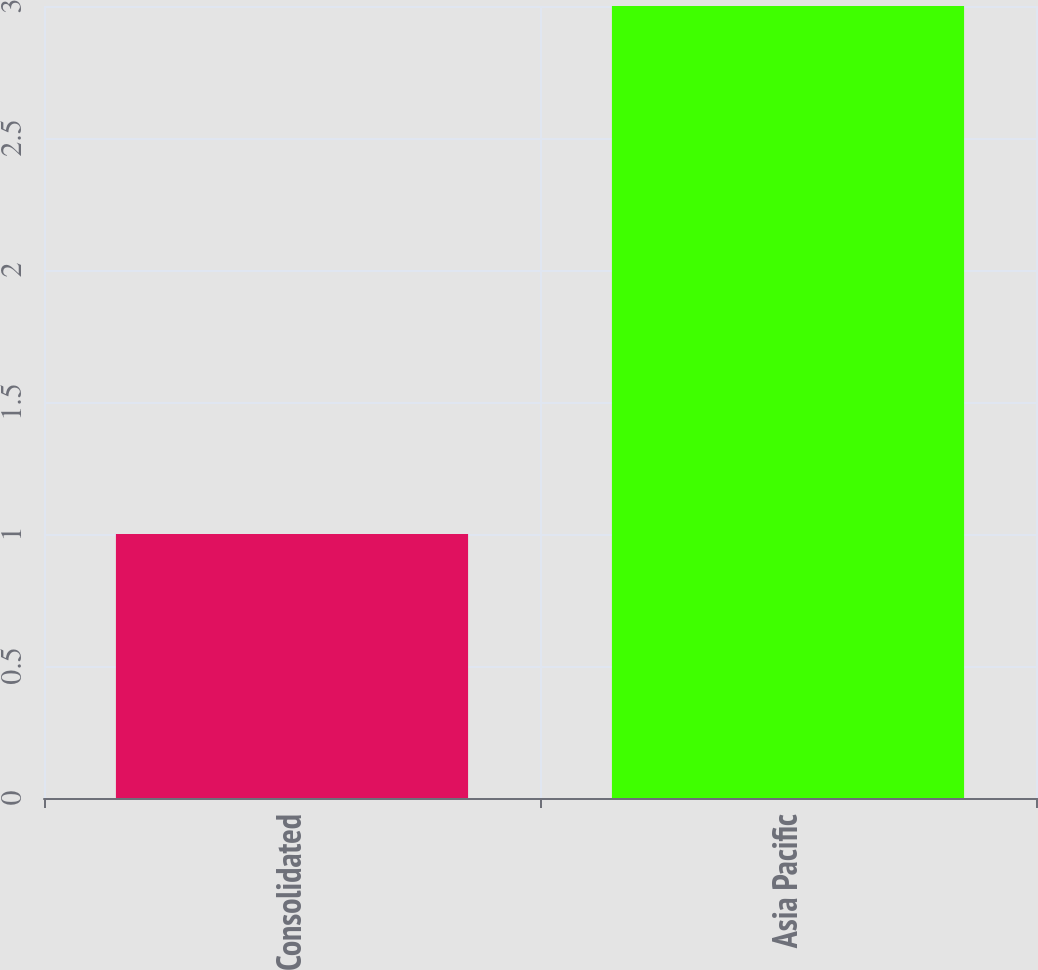<chart> <loc_0><loc_0><loc_500><loc_500><bar_chart><fcel>Consolidated<fcel>Asia Pacific<nl><fcel>1<fcel>3<nl></chart> 